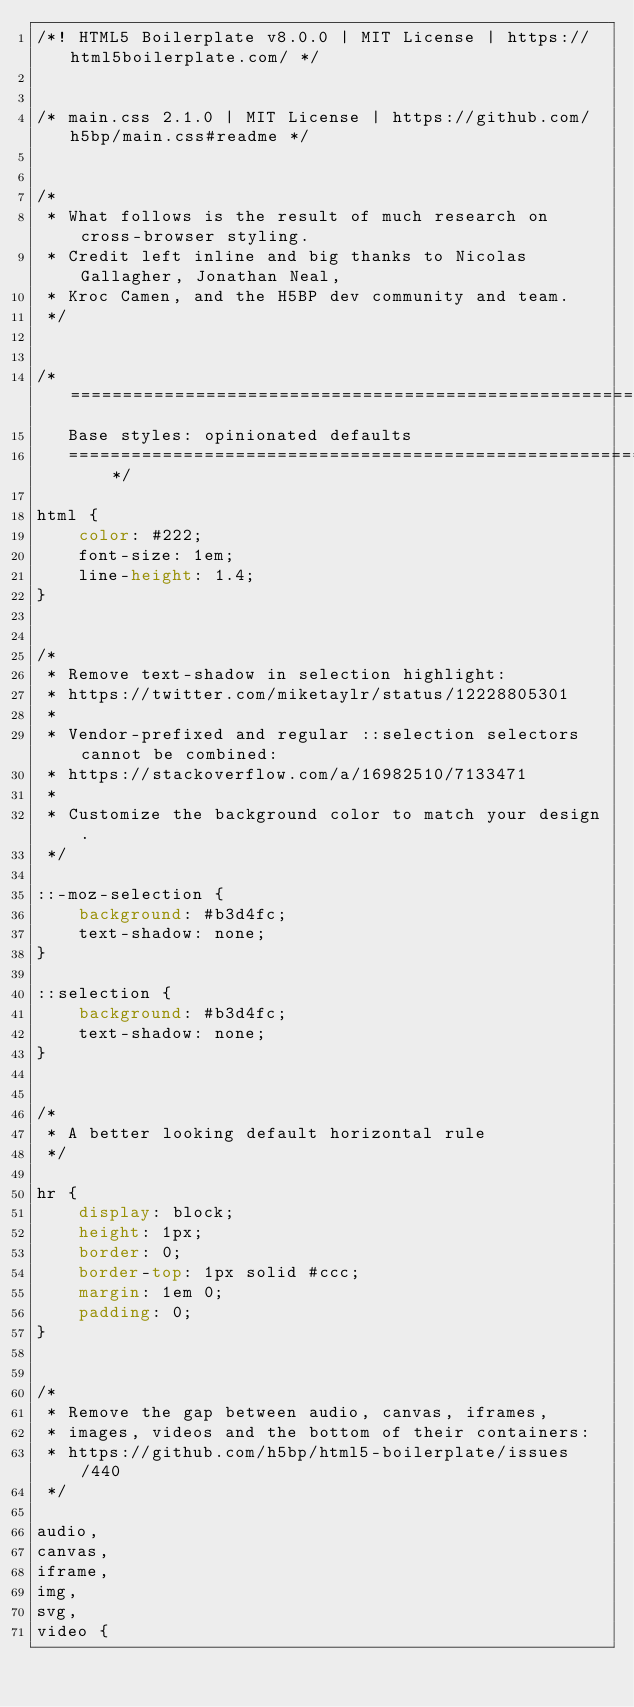Convert code to text. <code><loc_0><loc_0><loc_500><loc_500><_CSS_>/*! HTML5 Boilerplate v8.0.0 | MIT License | https://html5boilerplate.com/ */


/* main.css 2.1.0 | MIT License | https://github.com/h5bp/main.css#readme */


/*
 * What follows is the result of much research on cross-browser styling.
 * Credit left inline and big thanks to Nicolas Gallagher, Jonathan Neal,
 * Kroc Camen, and the H5BP dev community and team.
 */


/* ==========================================================================
   Base styles: opinionated defaults
   ========================================================================== */

html {
    color: #222;
    font-size: 1em;
    line-height: 1.4;
}


/*
 * Remove text-shadow in selection highlight:
 * https://twitter.com/miketaylr/status/12228805301
 *
 * Vendor-prefixed and regular ::selection selectors cannot be combined:
 * https://stackoverflow.com/a/16982510/7133471
 *
 * Customize the background color to match your design.
 */

::-moz-selection {
    background: #b3d4fc;
    text-shadow: none;
}

::selection {
    background: #b3d4fc;
    text-shadow: none;
}


/*
 * A better looking default horizontal rule
 */

hr {
    display: block;
    height: 1px;
    border: 0;
    border-top: 1px solid #ccc;
    margin: 1em 0;
    padding: 0;
}


/*
 * Remove the gap between audio, canvas, iframes,
 * images, videos and the bottom of their containers:
 * https://github.com/h5bp/html5-boilerplate/issues/440
 */

audio,
canvas,
iframe,
img,
svg,
video {</code> 